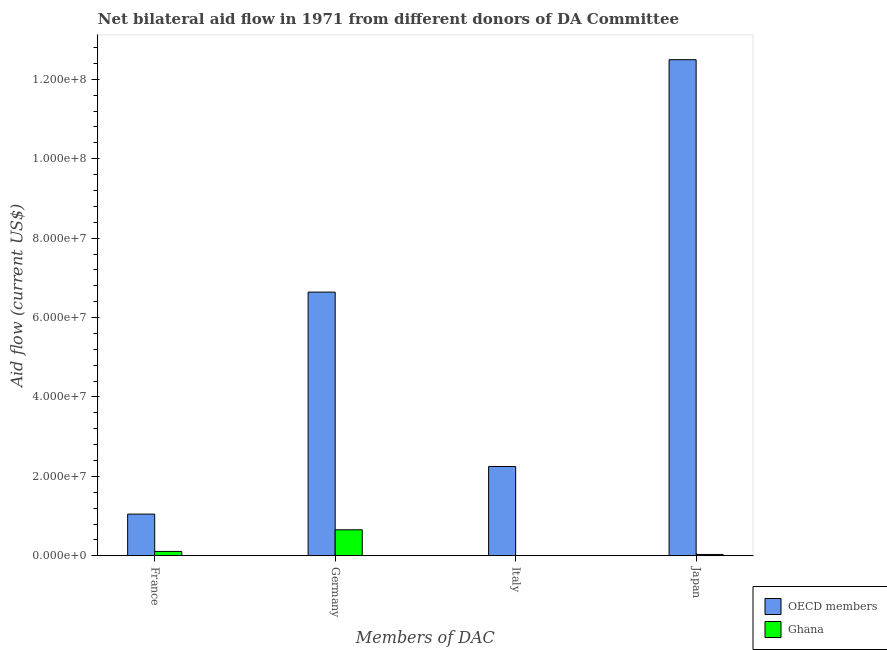How many different coloured bars are there?
Offer a terse response. 2. What is the label of the 4th group of bars from the left?
Keep it short and to the point. Japan. What is the amount of aid given by france in Ghana?
Offer a very short reply. 1.10e+06. Across all countries, what is the maximum amount of aid given by france?
Your answer should be very brief. 1.05e+07. Across all countries, what is the minimum amount of aid given by france?
Your answer should be very brief. 1.10e+06. What is the total amount of aid given by france in the graph?
Provide a short and direct response. 1.16e+07. What is the difference between the amount of aid given by france in Ghana and that in OECD members?
Give a very brief answer. -9.40e+06. What is the difference between the amount of aid given by japan in Ghana and the amount of aid given by italy in OECD members?
Your answer should be very brief. -2.22e+07. What is the average amount of aid given by japan per country?
Provide a succinct answer. 6.26e+07. What is the difference between the amount of aid given by japan and amount of aid given by germany in OECD members?
Offer a terse response. 5.85e+07. In how many countries, is the amount of aid given by italy greater than 116000000 US$?
Provide a succinct answer. 0. What is the ratio of the amount of aid given by france in Ghana to that in OECD members?
Give a very brief answer. 0.1. Is the amount of aid given by japan in Ghana less than that in OECD members?
Keep it short and to the point. Yes. What is the difference between the highest and the second highest amount of aid given by france?
Offer a terse response. 9.40e+06. What is the difference between the highest and the lowest amount of aid given by japan?
Ensure brevity in your answer.  1.25e+08. Is the sum of the amount of aid given by france in Ghana and OECD members greater than the maximum amount of aid given by italy across all countries?
Your response must be concise. No. Is it the case that in every country, the sum of the amount of aid given by france and amount of aid given by germany is greater than the amount of aid given by italy?
Provide a short and direct response. Yes. Are all the bars in the graph horizontal?
Provide a short and direct response. No. How many countries are there in the graph?
Your answer should be compact. 2. Does the graph contain any zero values?
Ensure brevity in your answer.  Yes. Does the graph contain grids?
Offer a terse response. No. How many legend labels are there?
Offer a very short reply. 2. What is the title of the graph?
Your response must be concise. Net bilateral aid flow in 1971 from different donors of DA Committee. Does "Hungary" appear as one of the legend labels in the graph?
Offer a terse response. No. What is the label or title of the X-axis?
Your answer should be very brief. Members of DAC. What is the Aid flow (current US$) of OECD members in France?
Keep it short and to the point. 1.05e+07. What is the Aid flow (current US$) in Ghana in France?
Offer a very short reply. 1.10e+06. What is the Aid flow (current US$) of OECD members in Germany?
Ensure brevity in your answer.  6.64e+07. What is the Aid flow (current US$) of Ghana in Germany?
Your answer should be very brief. 6.54e+06. What is the Aid flow (current US$) of OECD members in Italy?
Give a very brief answer. 2.25e+07. What is the Aid flow (current US$) of OECD members in Japan?
Offer a terse response. 1.25e+08. Across all Members of DAC, what is the maximum Aid flow (current US$) in OECD members?
Your answer should be compact. 1.25e+08. Across all Members of DAC, what is the maximum Aid flow (current US$) of Ghana?
Give a very brief answer. 6.54e+06. Across all Members of DAC, what is the minimum Aid flow (current US$) in OECD members?
Offer a terse response. 1.05e+07. Across all Members of DAC, what is the minimum Aid flow (current US$) in Ghana?
Ensure brevity in your answer.  0. What is the total Aid flow (current US$) of OECD members in the graph?
Your answer should be very brief. 2.24e+08. What is the total Aid flow (current US$) of Ghana in the graph?
Offer a very short reply. 7.98e+06. What is the difference between the Aid flow (current US$) in OECD members in France and that in Germany?
Provide a succinct answer. -5.59e+07. What is the difference between the Aid flow (current US$) of Ghana in France and that in Germany?
Provide a succinct answer. -5.44e+06. What is the difference between the Aid flow (current US$) of OECD members in France and that in Italy?
Your answer should be very brief. -1.20e+07. What is the difference between the Aid flow (current US$) in OECD members in France and that in Japan?
Give a very brief answer. -1.14e+08. What is the difference between the Aid flow (current US$) in Ghana in France and that in Japan?
Ensure brevity in your answer.  7.60e+05. What is the difference between the Aid flow (current US$) of OECD members in Germany and that in Italy?
Keep it short and to the point. 4.39e+07. What is the difference between the Aid flow (current US$) of OECD members in Germany and that in Japan?
Make the answer very short. -5.85e+07. What is the difference between the Aid flow (current US$) of Ghana in Germany and that in Japan?
Make the answer very short. 6.20e+06. What is the difference between the Aid flow (current US$) of OECD members in Italy and that in Japan?
Provide a succinct answer. -1.02e+08. What is the difference between the Aid flow (current US$) of OECD members in France and the Aid flow (current US$) of Ghana in Germany?
Keep it short and to the point. 3.96e+06. What is the difference between the Aid flow (current US$) in OECD members in France and the Aid flow (current US$) in Ghana in Japan?
Your answer should be very brief. 1.02e+07. What is the difference between the Aid flow (current US$) of OECD members in Germany and the Aid flow (current US$) of Ghana in Japan?
Offer a very short reply. 6.61e+07. What is the difference between the Aid flow (current US$) in OECD members in Italy and the Aid flow (current US$) in Ghana in Japan?
Your response must be concise. 2.22e+07. What is the average Aid flow (current US$) in OECD members per Members of DAC?
Offer a terse response. 5.61e+07. What is the average Aid flow (current US$) in Ghana per Members of DAC?
Offer a terse response. 2.00e+06. What is the difference between the Aid flow (current US$) in OECD members and Aid flow (current US$) in Ghana in France?
Your response must be concise. 9.40e+06. What is the difference between the Aid flow (current US$) in OECD members and Aid flow (current US$) in Ghana in Germany?
Offer a very short reply. 5.99e+07. What is the difference between the Aid flow (current US$) of OECD members and Aid flow (current US$) of Ghana in Japan?
Your answer should be very brief. 1.25e+08. What is the ratio of the Aid flow (current US$) in OECD members in France to that in Germany?
Provide a succinct answer. 0.16. What is the ratio of the Aid flow (current US$) in Ghana in France to that in Germany?
Give a very brief answer. 0.17. What is the ratio of the Aid flow (current US$) in OECD members in France to that in Italy?
Keep it short and to the point. 0.47. What is the ratio of the Aid flow (current US$) in OECD members in France to that in Japan?
Your answer should be very brief. 0.08. What is the ratio of the Aid flow (current US$) in Ghana in France to that in Japan?
Your response must be concise. 3.24. What is the ratio of the Aid flow (current US$) in OECD members in Germany to that in Italy?
Your response must be concise. 2.95. What is the ratio of the Aid flow (current US$) of OECD members in Germany to that in Japan?
Offer a very short reply. 0.53. What is the ratio of the Aid flow (current US$) in Ghana in Germany to that in Japan?
Your response must be concise. 19.24. What is the ratio of the Aid flow (current US$) of OECD members in Italy to that in Japan?
Provide a short and direct response. 0.18. What is the difference between the highest and the second highest Aid flow (current US$) of OECD members?
Make the answer very short. 5.85e+07. What is the difference between the highest and the second highest Aid flow (current US$) in Ghana?
Provide a succinct answer. 5.44e+06. What is the difference between the highest and the lowest Aid flow (current US$) of OECD members?
Provide a succinct answer. 1.14e+08. What is the difference between the highest and the lowest Aid flow (current US$) in Ghana?
Keep it short and to the point. 6.54e+06. 